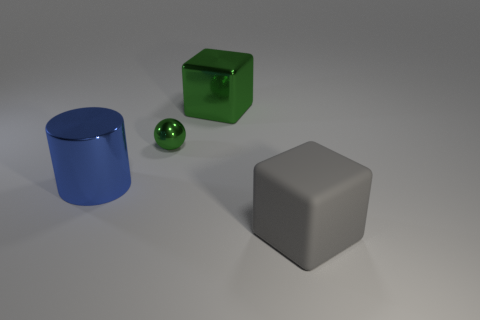What number of spheres are the same size as the gray block?
Offer a terse response. 0. Does the gray rubber object have the same shape as the large green thing?
Make the answer very short. Yes. What is the color of the block behind the cube in front of the big cylinder?
Your answer should be very brief. Green. How big is the metal object that is both right of the cylinder and in front of the large green block?
Your response must be concise. Small. Are there any other things that have the same color as the sphere?
Provide a succinct answer. Yes. There is a large green object that is made of the same material as the big blue cylinder; what shape is it?
Offer a very short reply. Cube. Do the gray object and the large shiny thing that is in front of the green ball have the same shape?
Provide a short and direct response. No. What material is the cube that is in front of the big block that is behind the gray matte cube?
Ensure brevity in your answer.  Rubber. Are there an equal number of blocks to the left of the big shiny cylinder and tiny purple cylinders?
Your response must be concise. Yes. Are there any other things that are made of the same material as the big gray cube?
Provide a short and direct response. No. 